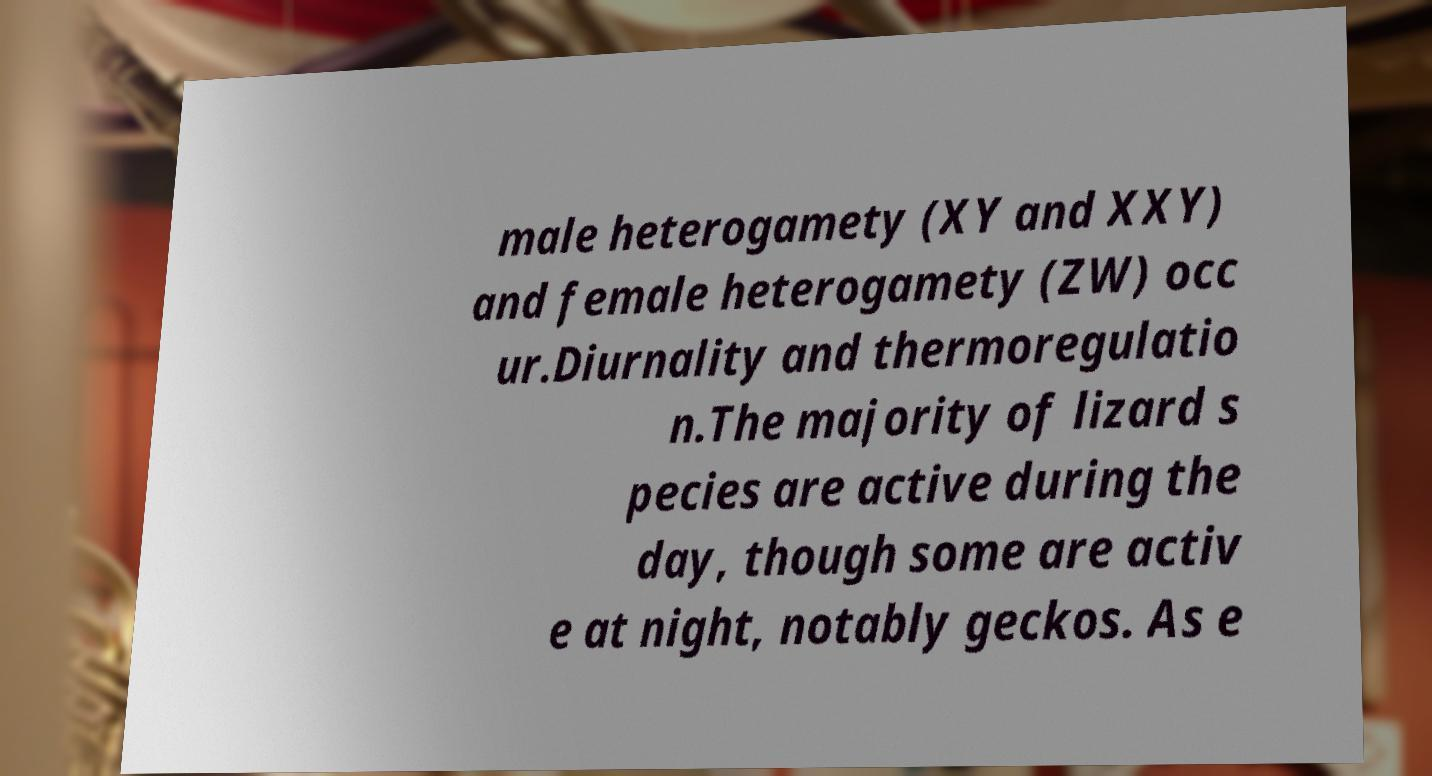For documentation purposes, I need the text within this image transcribed. Could you provide that? male heterogamety (XY and XXY) and female heterogamety (ZW) occ ur.Diurnality and thermoregulatio n.The majority of lizard s pecies are active during the day, though some are activ e at night, notably geckos. As e 